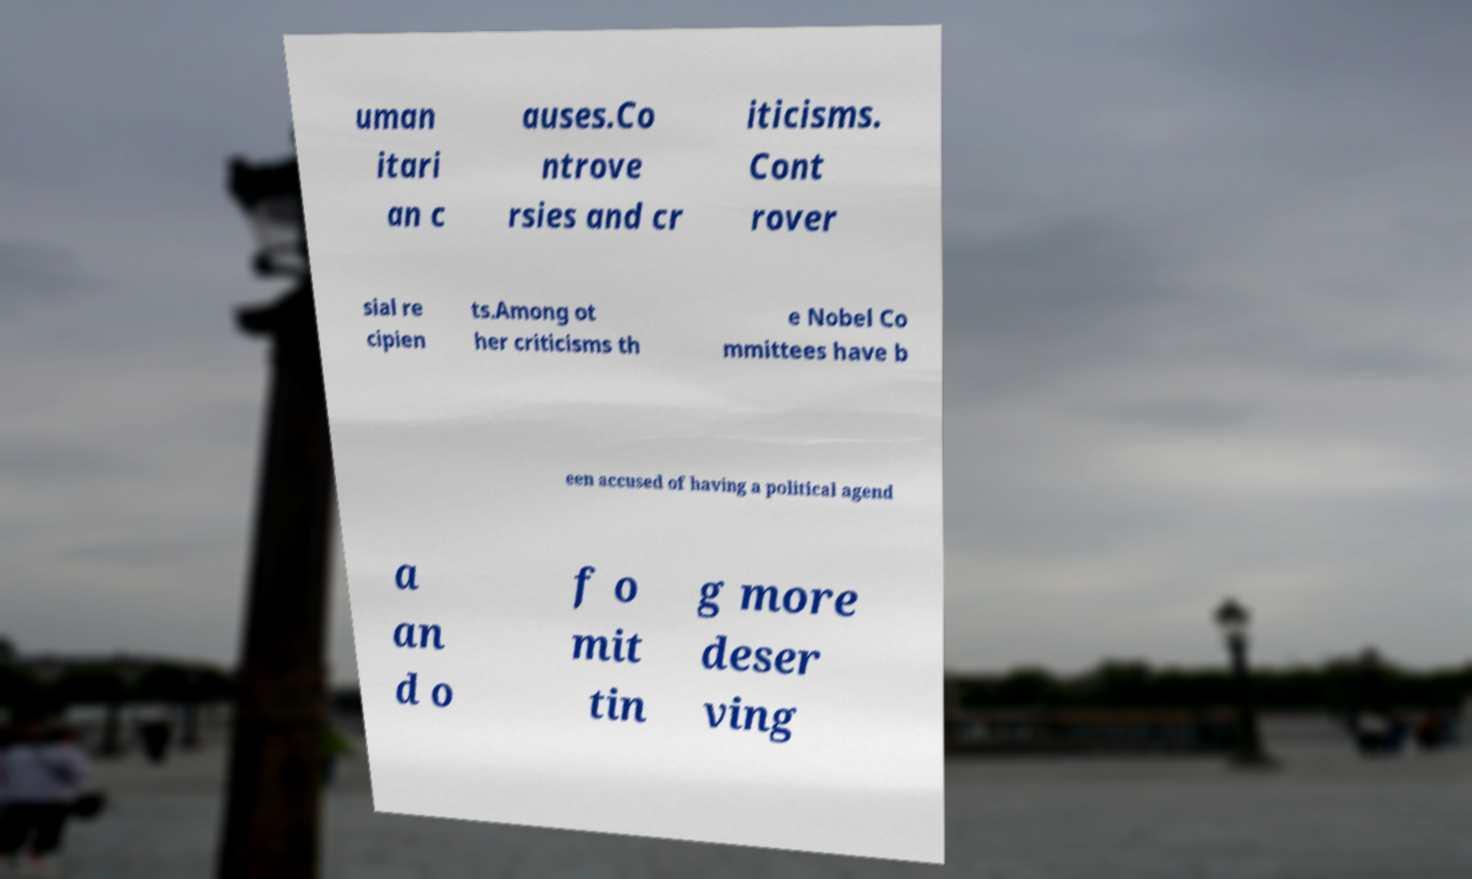There's text embedded in this image that I need extracted. Can you transcribe it verbatim? uman itari an c auses.Co ntrove rsies and cr iticisms. Cont rover sial re cipien ts.Among ot her criticisms th e Nobel Co mmittees have b een accused of having a political agend a an d o f o mit tin g more deser ving 